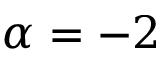<formula> <loc_0><loc_0><loc_500><loc_500>\alpha = - 2</formula> 